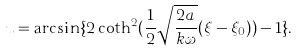Convert formula to latex. <formula><loc_0><loc_0><loc_500><loc_500>u = \arcsin \{ 2 \coth ^ { 2 } ( \frac { 1 } { 2 } \sqrt { \frac { 2 a } { k \omega } } ( \xi - { \xi } _ { 0 } ) ) - 1 \} .</formula> 